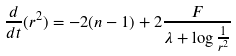Convert formula to latex. <formula><loc_0><loc_0><loc_500><loc_500>\frac { d } { d t } ( r ^ { 2 } ) = - 2 ( n - 1 ) + 2 \frac { F } { \lambda + \log \frac { 1 } { r ^ { 2 } } }</formula> 